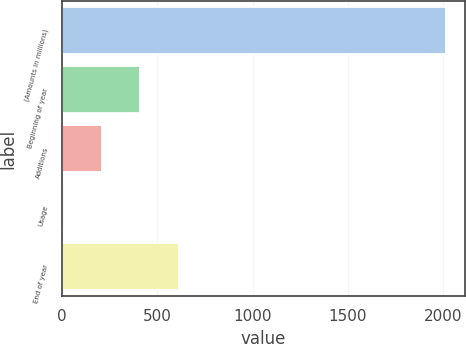<chart> <loc_0><loc_0><loc_500><loc_500><bar_chart><fcel>(Amounts in millions)<fcel>Beginning of year<fcel>Additions<fcel>Usage<fcel>End of year<nl><fcel>2012<fcel>410.48<fcel>210.29<fcel>10.1<fcel>610.67<nl></chart> 